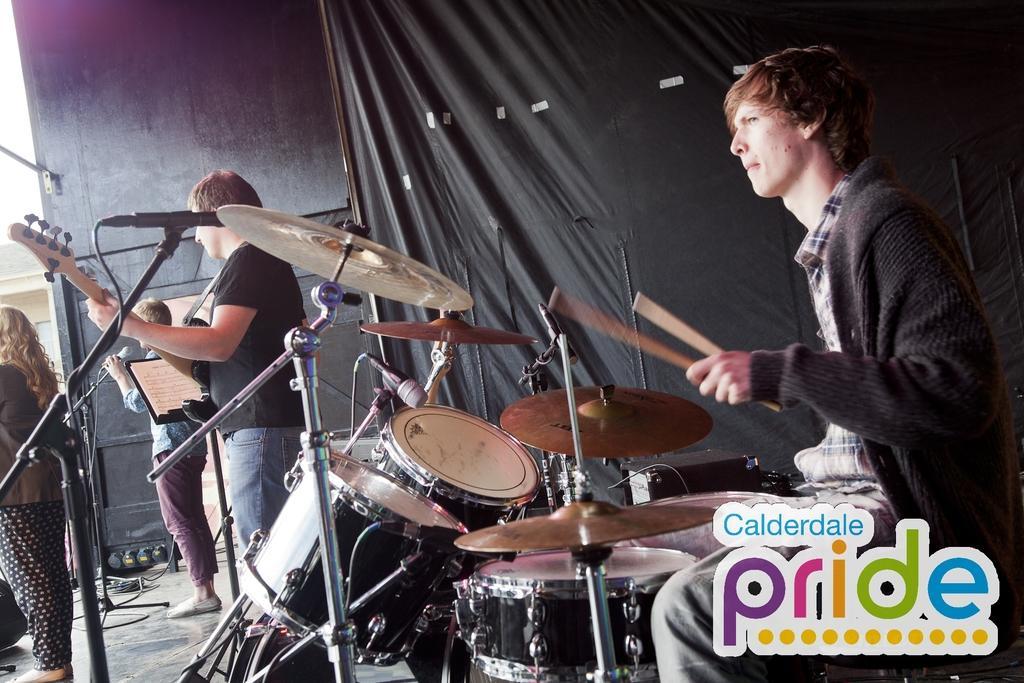Please provide a concise description of this image. This Picture describe that four people are performing the musical band, On the right a boy wearing black sweater is sitting on the chair and playing Band, Beside him a boy standing and playing the guitar, on the extreme left corner a boy playing guitar and a girl stand in font of the stage, Behind we can see a black color sheer curtain. 